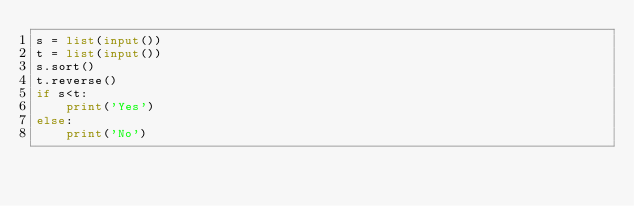Convert code to text. <code><loc_0><loc_0><loc_500><loc_500><_Python_>s = list(input())
t = list(input())
s.sort()
t.reverse()
if s<t:
    print('Yes')
else:
    print('No')</code> 